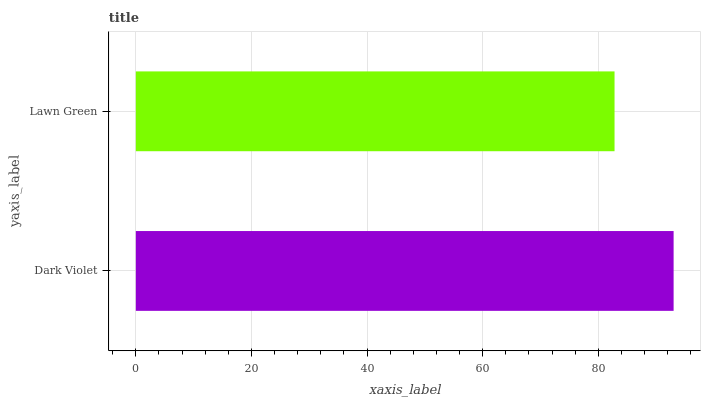Is Lawn Green the minimum?
Answer yes or no. Yes. Is Dark Violet the maximum?
Answer yes or no. Yes. Is Lawn Green the maximum?
Answer yes or no. No. Is Dark Violet greater than Lawn Green?
Answer yes or no. Yes. Is Lawn Green less than Dark Violet?
Answer yes or no. Yes. Is Lawn Green greater than Dark Violet?
Answer yes or no. No. Is Dark Violet less than Lawn Green?
Answer yes or no. No. Is Dark Violet the high median?
Answer yes or no. Yes. Is Lawn Green the low median?
Answer yes or no. Yes. Is Lawn Green the high median?
Answer yes or no. No. Is Dark Violet the low median?
Answer yes or no. No. 